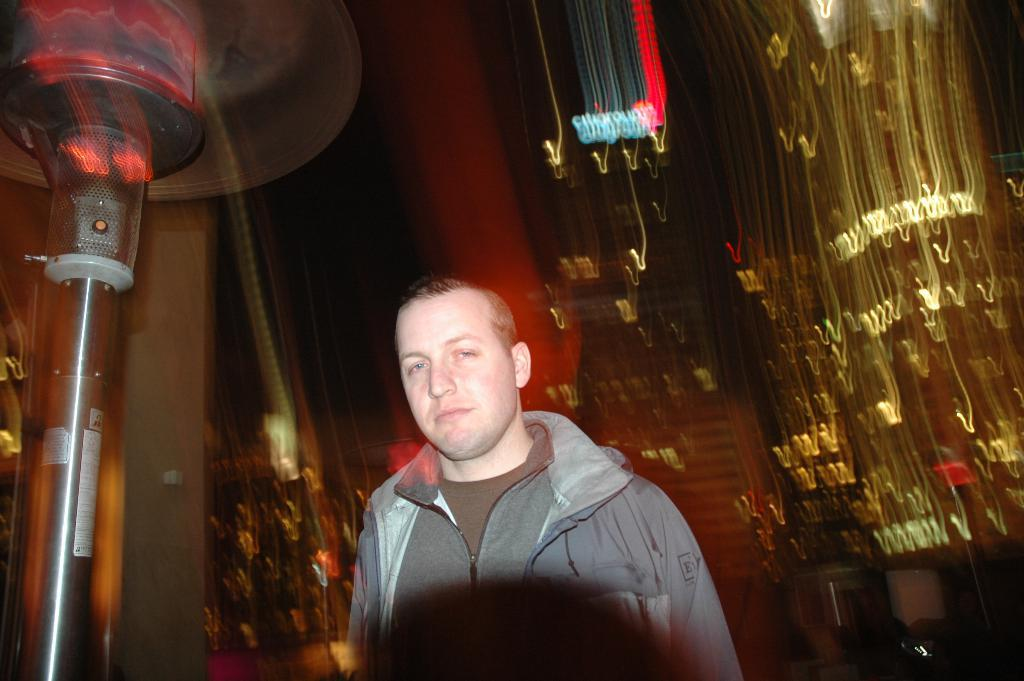Who is present in the image? There is a man in the image. What can be seen in the background of the image? There are light decorations in the background of the image. What is located on the left side of the image? There is an object on the left side of the image. What type of hose can be seen in the image? There is no hose present in the image. What angle is the man standing at in the image? The angle at which the man is standing cannot be determined from the image alone, as it only provides a two-dimensional representation. 